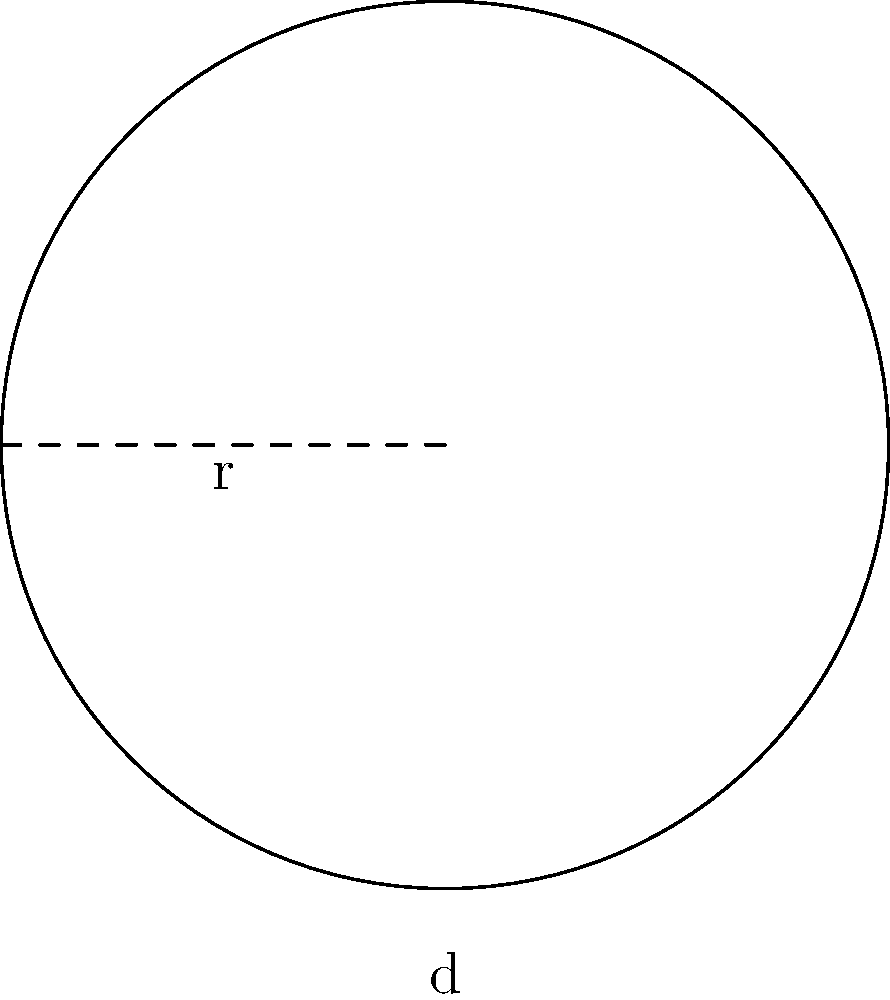As a knitting enthusiast, you're planning to create a circular pattern for a charity project. The pattern has a diameter of 20 inches. If you need to knit 3 complete rounds for the pattern, how many inches of yarn will you need? (Use $\pi \approx 3.14$) To solve this problem, let's follow these steps:

1) First, we need to find the circumference of the circle. The formula for circumference is:
   $C = \pi d$, where $d$ is the diameter.

2) We're given that the diameter is 20 inches, so let's substitute this into our formula:
   $C = \pi \times 20$

3) We're told to use $\pi \approx 3.14$, so:
   $C = 3.14 \times 20 = 62.8$ inches

4) This is the length of yarn needed for one complete round. However, we need to knit 3 complete rounds.

5) So, we multiply our result by 3:
   $62.8 \times 3 = 188.4$ inches

Therefore, you will need 188.4 inches of yarn to complete 3 rounds of the circular pattern.
Answer: 188.4 inches 